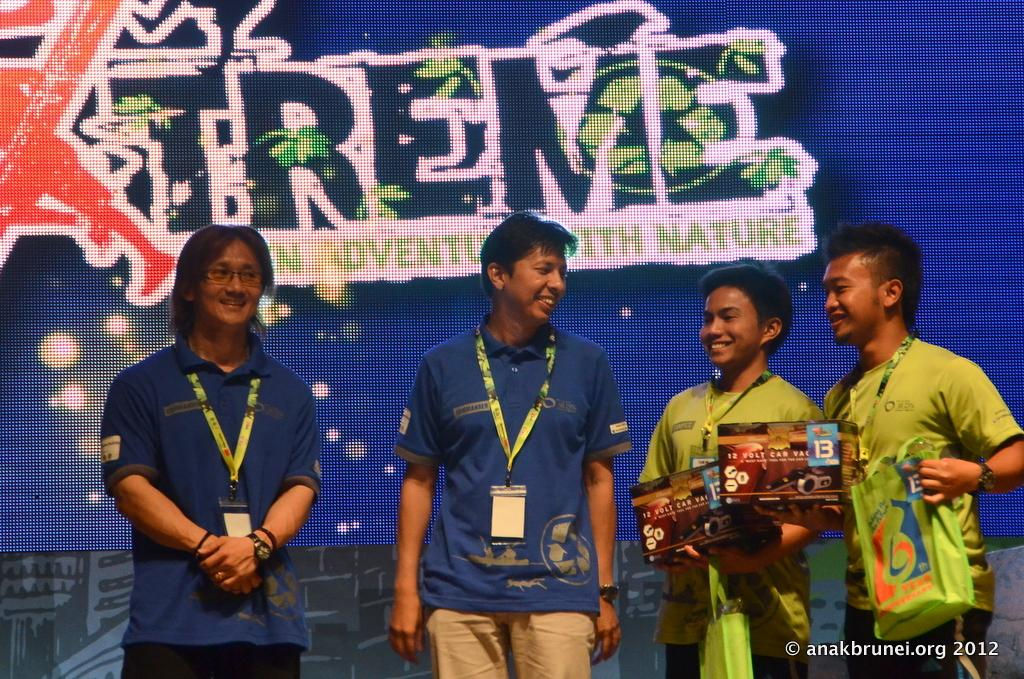What can be seen in the image? There are people standing in the image. What are the people wearing? The people are wearing ID cards. What is visible in the background of the image? There is a poster in the background of the image. How many geese are flying in the image? There are no geese present in the image. What type of company is represented by the people in the image? The provided facts do not give any information about the company or organization the people might be associated with. 